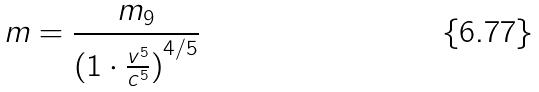Convert formula to latex. <formula><loc_0><loc_0><loc_500><loc_500>m = \frac { m _ { 9 } } { ( { 1 \cdot \frac { v ^ { 5 } } { c ^ { 5 } } ) } ^ { 4 / 5 } }</formula> 